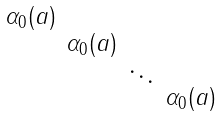Convert formula to latex. <formula><loc_0><loc_0><loc_500><loc_500>\begin{smallmatrix} \alpha _ { 0 } ( a ) & & & \\ & \alpha _ { 0 } ( a ) & & \\ & & \ddots & \\ & & & \alpha _ { 0 } ( a ) \end{smallmatrix}</formula> 